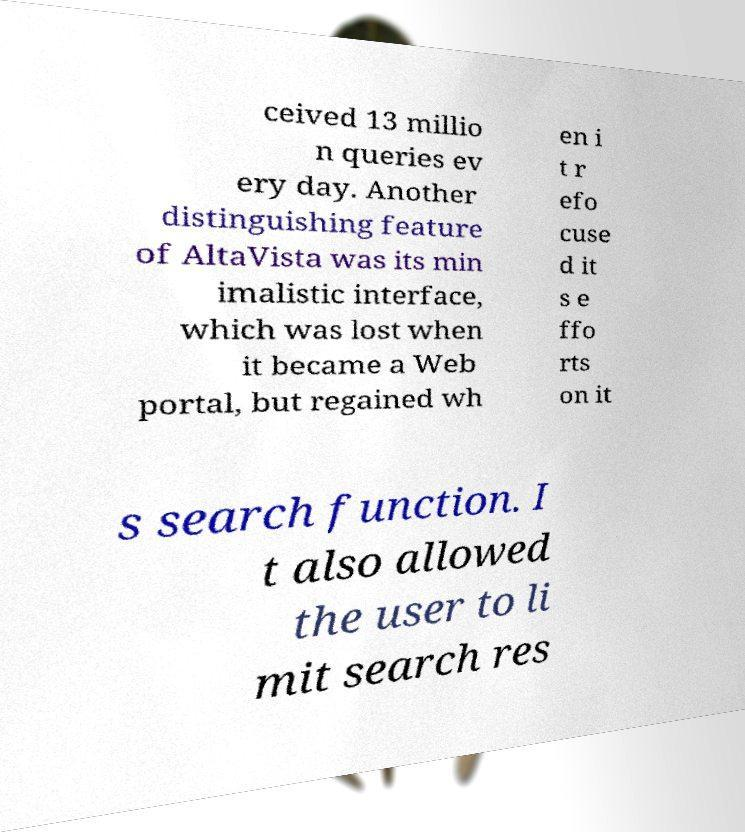Could you extract and type out the text from this image? ceived 13 millio n queries ev ery day. Another distinguishing feature of AltaVista was its min imalistic interface, which was lost when it became a Web portal, but regained wh en i t r efo cuse d it s e ffo rts on it s search function. I t also allowed the user to li mit search res 